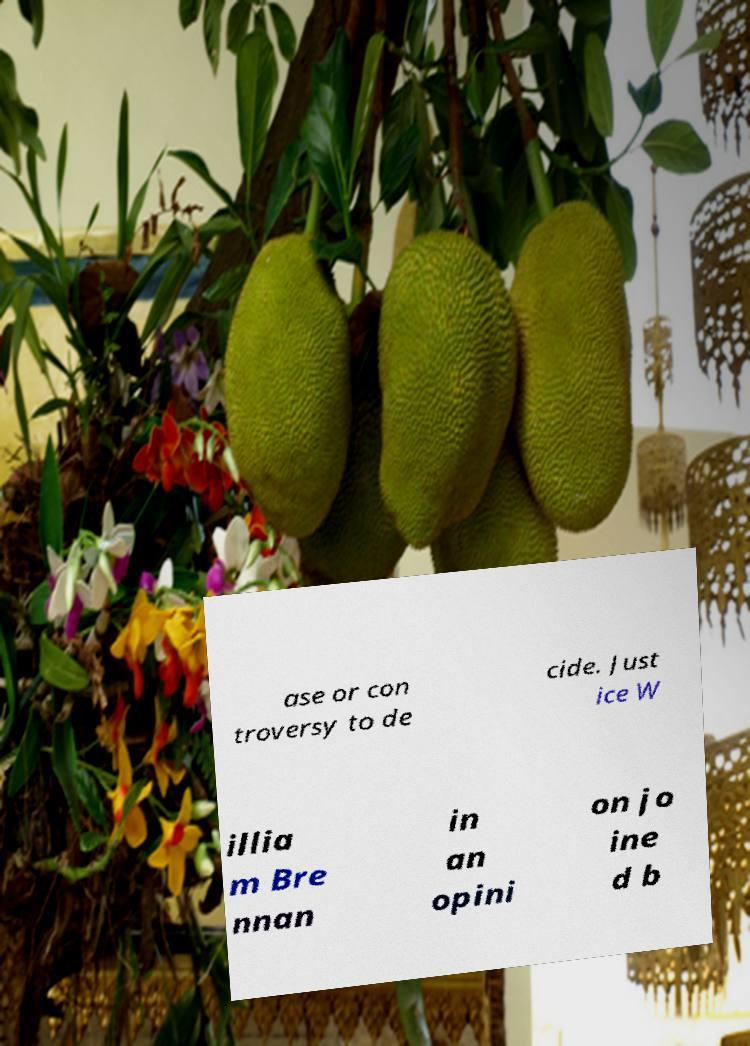Can you accurately transcribe the text from the provided image for me? ase or con troversy to de cide. Just ice W illia m Bre nnan in an opini on jo ine d b 